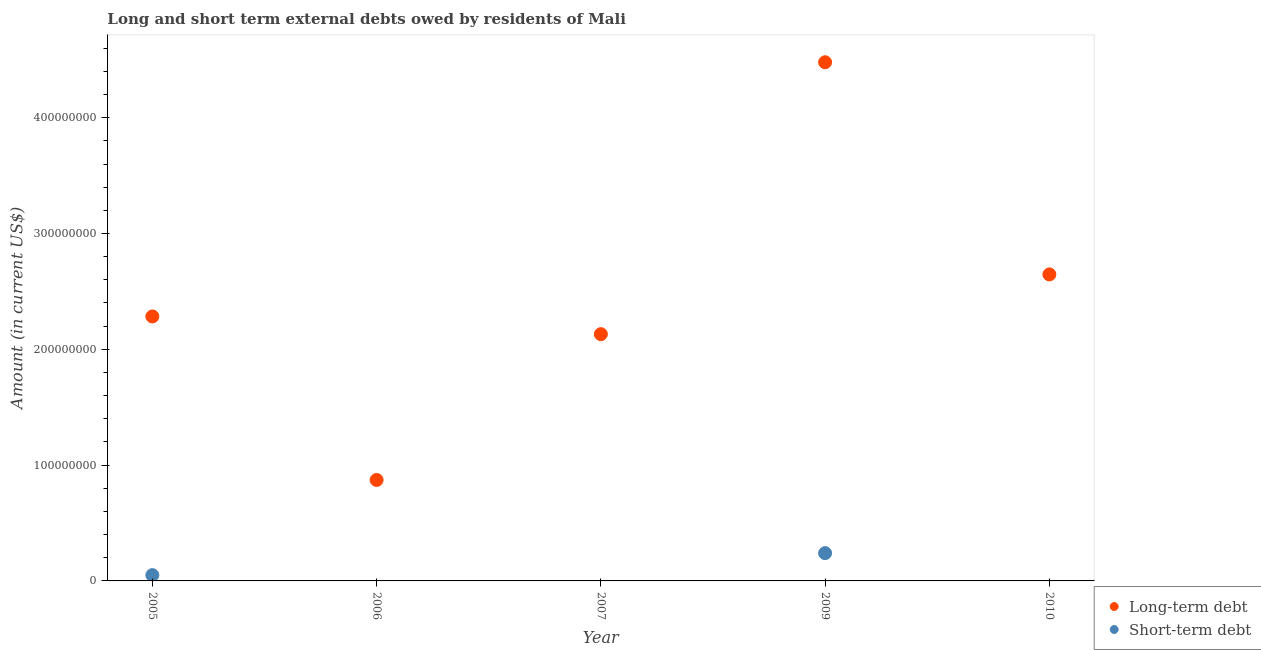How many different coloured dotlines are there?
Your response must be concise. 2. What is the short-term debts owed by residents in 2005?
Your response must be concise. 5.00e+06. Across all years, what is the maximum long-term debts owed by residents?
Keep it short and to the point. 4.48e+08. Across all years, what is the minimum long-term debts owed by residents?
Offer a very short reply. 8.72e+07. What is the total long-term debts owed by residents in the graph?
Provide a short and direct response. 1.24e+09. What is the difference between the long-term debts owed by residents in 2006 and that in 2007?
Provide a short and direct response. -1.26e+08. What is the difference between the long-term debts owed by residents in 2007 and the short-term debts owed by residents in 2009?
Make the answer very short. 1.89e+08. What is the average short-term debts owed by residents per year?
Offer a terse response. 5.80e+06. In the year 2009, what is the difference between the short-term debts owed by residents and long-term debts owed by residents?
Make the answer very short. -4.24e+08. In how many years, is the short-term debts owed by residents greater than 120000000 US$?
Make the answer very short. 0. What is the ratio of the long-term debts owed by residents in 2007 to that in 2010?
Provide a succinct answer. 0.81. What is the difference between the highest and the second highest long-term debts owed by residents?
Make the answer very short. 1.83e+08. What is the difference between the highest and the lowest long-term debts owed by residents?
Your response must be concise. 3.61e+08. In how many years, is the short-term debts owed by residents greater than the average short-term debts owed by residents taken over all years?
Keep it short and to the point. 1. Is the short-term debts owed by residents strictly less than the long-term debts owed by residents over the years?
Ensure brevity in your answer.  Yes. How many dotlines are there?
Offer a terse response. 2. Does the graph contain grids?
Offer a terse response. No. Where does the legend appear in the graph?
Provide a succinct answer. Bottom right. What is the title of the graph?
Your answer should be compact. Long and short term external debts owed by residents of Mali. Does "ODA received" appear as one of the legend labels in the graph?
Provide a short and direct response. No. What is the label or title of the X-axis?
Offer a very short reply. Year. What is the label or title of the Y-axis?
Provide a short and direct response. Amount (in current US$). What is the Amount (in current US$) in Long-term debt in 2005?
Your answer should be compact. 2.28e+08. What is the Amount (in current US$) of Short-term debt in 2005?
Provide a succinct answer. 5.00e+06. What is the Amount (in current US$) in Long-term debt in 2006?
Provide a succinct answer. 8.72e+07. What is the Amount (in current US$) in Long-term debt in 2007?
Your answer should be compact. 2.13e+08. What is the Amount (in current US$) in Long-term debt in 2009?
Your response must be concise. 4.48e+08. What is the Amount (in current US$) of Short-term debt in 2009?
Keep it short and to the point. 2.40e+07. What is the Amount (in current US$) in Long-term debt in 2010?
Make the answer very short. 2.65e+08. Across all years, what is the maximum Amount (in current US$) in Long-term debt?
Your answer should be very brief. 4.48e+08. Across all years, what is the maximum Amount (in current US$) in Short-term debt?
Offer a very short reply. 2.40e+07. Across all years, what is the minimum Amount (in current US$) of Long-term debt?
Provide a short and direct response. 8.72e+07. What is the total Amount (in current US$) in Long-term debt in the graph?
Your answer should be very brief. 1.24e+09. What is the total Amount (in current US$) of Short-term debt in the graph?
Give a very brief answer. 2.90e+07. What is the difference between the Amount (in current US$) in Long-term debt in 2005 and that in 2006?
Your answer should be very brief. 1.41e+08. What is the difference between the Amount (in current US$) in Long-term debt in 2005 and that in 2007?
Provide a short and direct response. 1.53e+07. What is the difference between the Amount (in current US$) in Long-term debt in 2005 and that in 2009?
Your answer should be very brief. -2.19e+08. What is the difference between the Amount (in current US$) of Short-term debt in 2005 and that in 2009?
Keep it short and to the point. -1.90e+07. What is the difference between the Amount (in current US$) of Long-term debt in 2005 and that in 2010?
Your answer should be compact. -3.63e+07. What is the difference between the Amount (in current US$) in Long-term debt in 2006 and that in 2007?
Provide a short and direct response. -1.26e+08. What is the difference between the Amount (in current US$) in Long-term debt in 2006 and that in 2009?
Provide a succinct answer. -3.61e+08. What is the difference between the Amount (in current US$) in Long-term debt in 2006 and that in 2010?
Your answer should be compact. -1.78e+08. What is the difference between the Amount (in current US$) in Long-term debt in 2007 and that in 2009?
Your response must be concise. -2.35e+08. What is the difference between the Amount (in current US$) in Long-term debt in 2007 and that in 2010?
Ensure brevity in your answer.  -5.16e+07. What is the difference between the Amount (in current US$) in Long-term debt in 2009 and that in 2010?
Make the answer very short. 1.83e+08. What is the difference between the Amount (in current US$) of Long-term debt in 2005 and the Amount (in current US$) of Short-term debt in 2009?
Provide a short and direct response. 2.04e+08. What is the difference between the Amount (in current US$) in Long-term debt in 2006 and the Amount (in current US$) in Short-term debt in 2009?
Keep it short and to the point. 6.32e+07. What is the difference between the Amount (in current US$) in Long-term debt in 2007 and the Amount (in current US$) in Short-term debt in 2009?
Your answer should be very brief. 1.89e+08. What is the average Amount (in current US$) of Long-term debt per year?
Ensure brevity in your answer.  2.48e+08. What is the average Amount (in current US$) in Short-term debt per year?
Provide a short and direct response. 5.80e+06. In the year 2005, what is the difference between the Amount (in current US$) in Long-term debt and Amount (in current US$) in Short-term debt?
Give a very brief answer. 2.23e+08. In the year 2009, what is the difference between the Amount (in current US$) of Long-term debt and Amount (in current US$) of Short-term debt?
Provide a succinct answer. 4.24e+08. What is the ratio of the Amount (in current US$) in Long-term debt in 2005 to that in 2006?
Provide a short and direct response. 2.62. What is the ratio of the Amount (in current US$) of Long-term debt in 2005 to that in 2007?
Your response must be concise. 1.07. What is the ratio of the Amount (in current US$) of Long-term debt in 2005 to that in 2009?
Your answer should be very brief. 0.51. What is the ratio of the Amount (in current US$) in Short-term debt in 2005 to that in 2009?
Provide a succinct answer. 0.21. What is the ratio of the Amount (in current US$) in Long-term debt in 2005 to that in 2010?
Your answer should be very brief. 0.86. What is the ratio of the Amount (in current US$) in Long-term debt in 2006 to that in 2007?
Your answer should be compact. 0.41. What is the ratio of the Amount (in current US$) of Long-term debt in 2006 to that in 2009?
Keep it short and to the point. 0.19. What is the ratio of the Amount (in current US$) of Long-term debt in 2006 to that in 2010?
Provide a short and direct response. 0.33. What is the ratio of the Amount (in current US$) of Long-term debt in 2007 to that in 2009?
Offer a very short reply. 0.48. What is the ratio of the Amount (in current US$) in Long-term debt in 2007 to that in 2010?
Your response must be concise. 0.81. What is the ratio of the Amount (in current US$) of Long-term debt in 2009 to that in 2010?
Make the answer very short. 1.69. What is the difference between the highest and the second highest Amount (in current US$) of Long-term debt?
Offer a very short reply. 1.83e+08. What is the difference between the highest and the lowest Amount (in current US$) in Long-term debt?
Provide a succinct answer. 3.61e+08. What is the difference between the highest and the lowest Amount (in current US$) of Short-term debt?
Make the answer very short. 2.40e+07. 